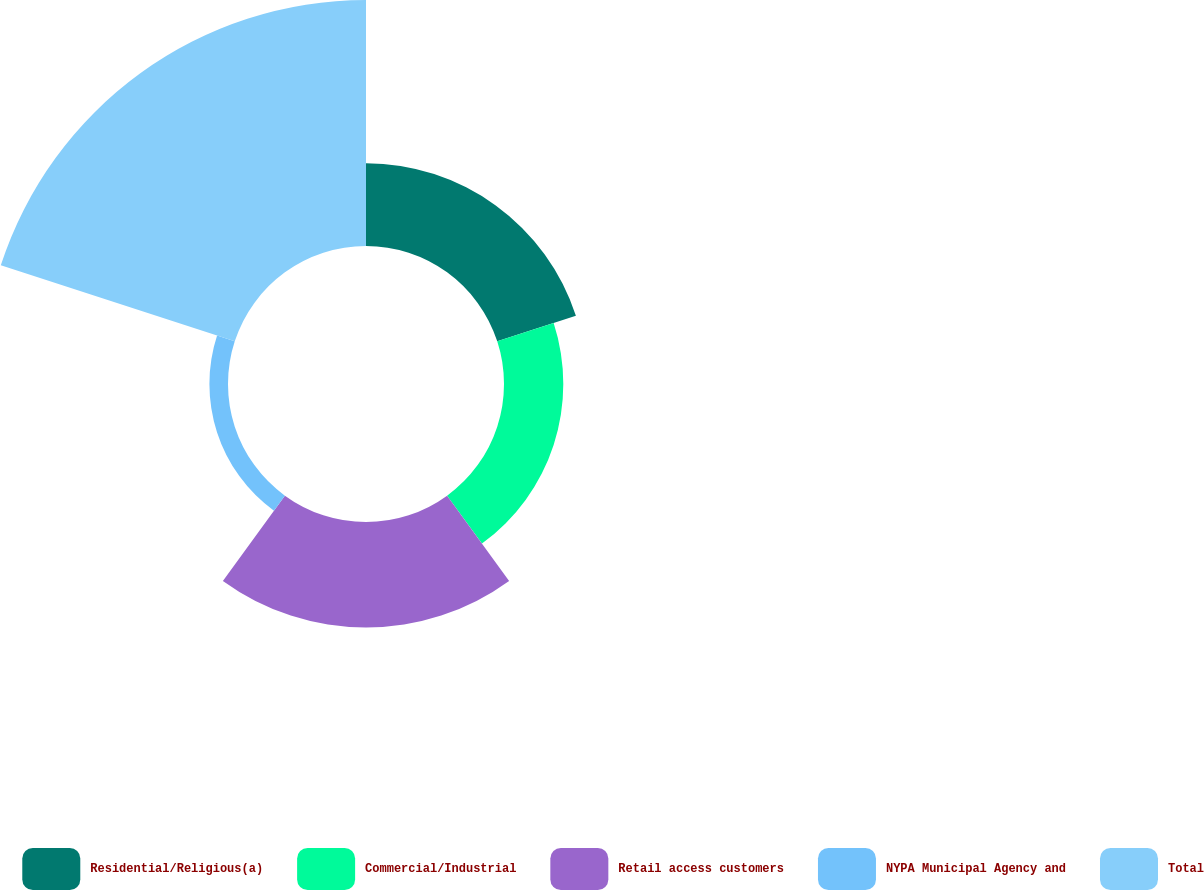Convert chart to OTSL. <chart><loc_0><loc_0><loc_500><loc_500><pie_chart><fcel>Residential/Religious(a)<fcel>Commercial/Industrial<fcel>Retail access customers<fcel>NYPA Municipal Agency and<fcel>Total<nl><fcel>16.15%<fcel>11.58%<fcel>20.6%<fcel>3.63%<fcel>48.04%<nl></chart> 